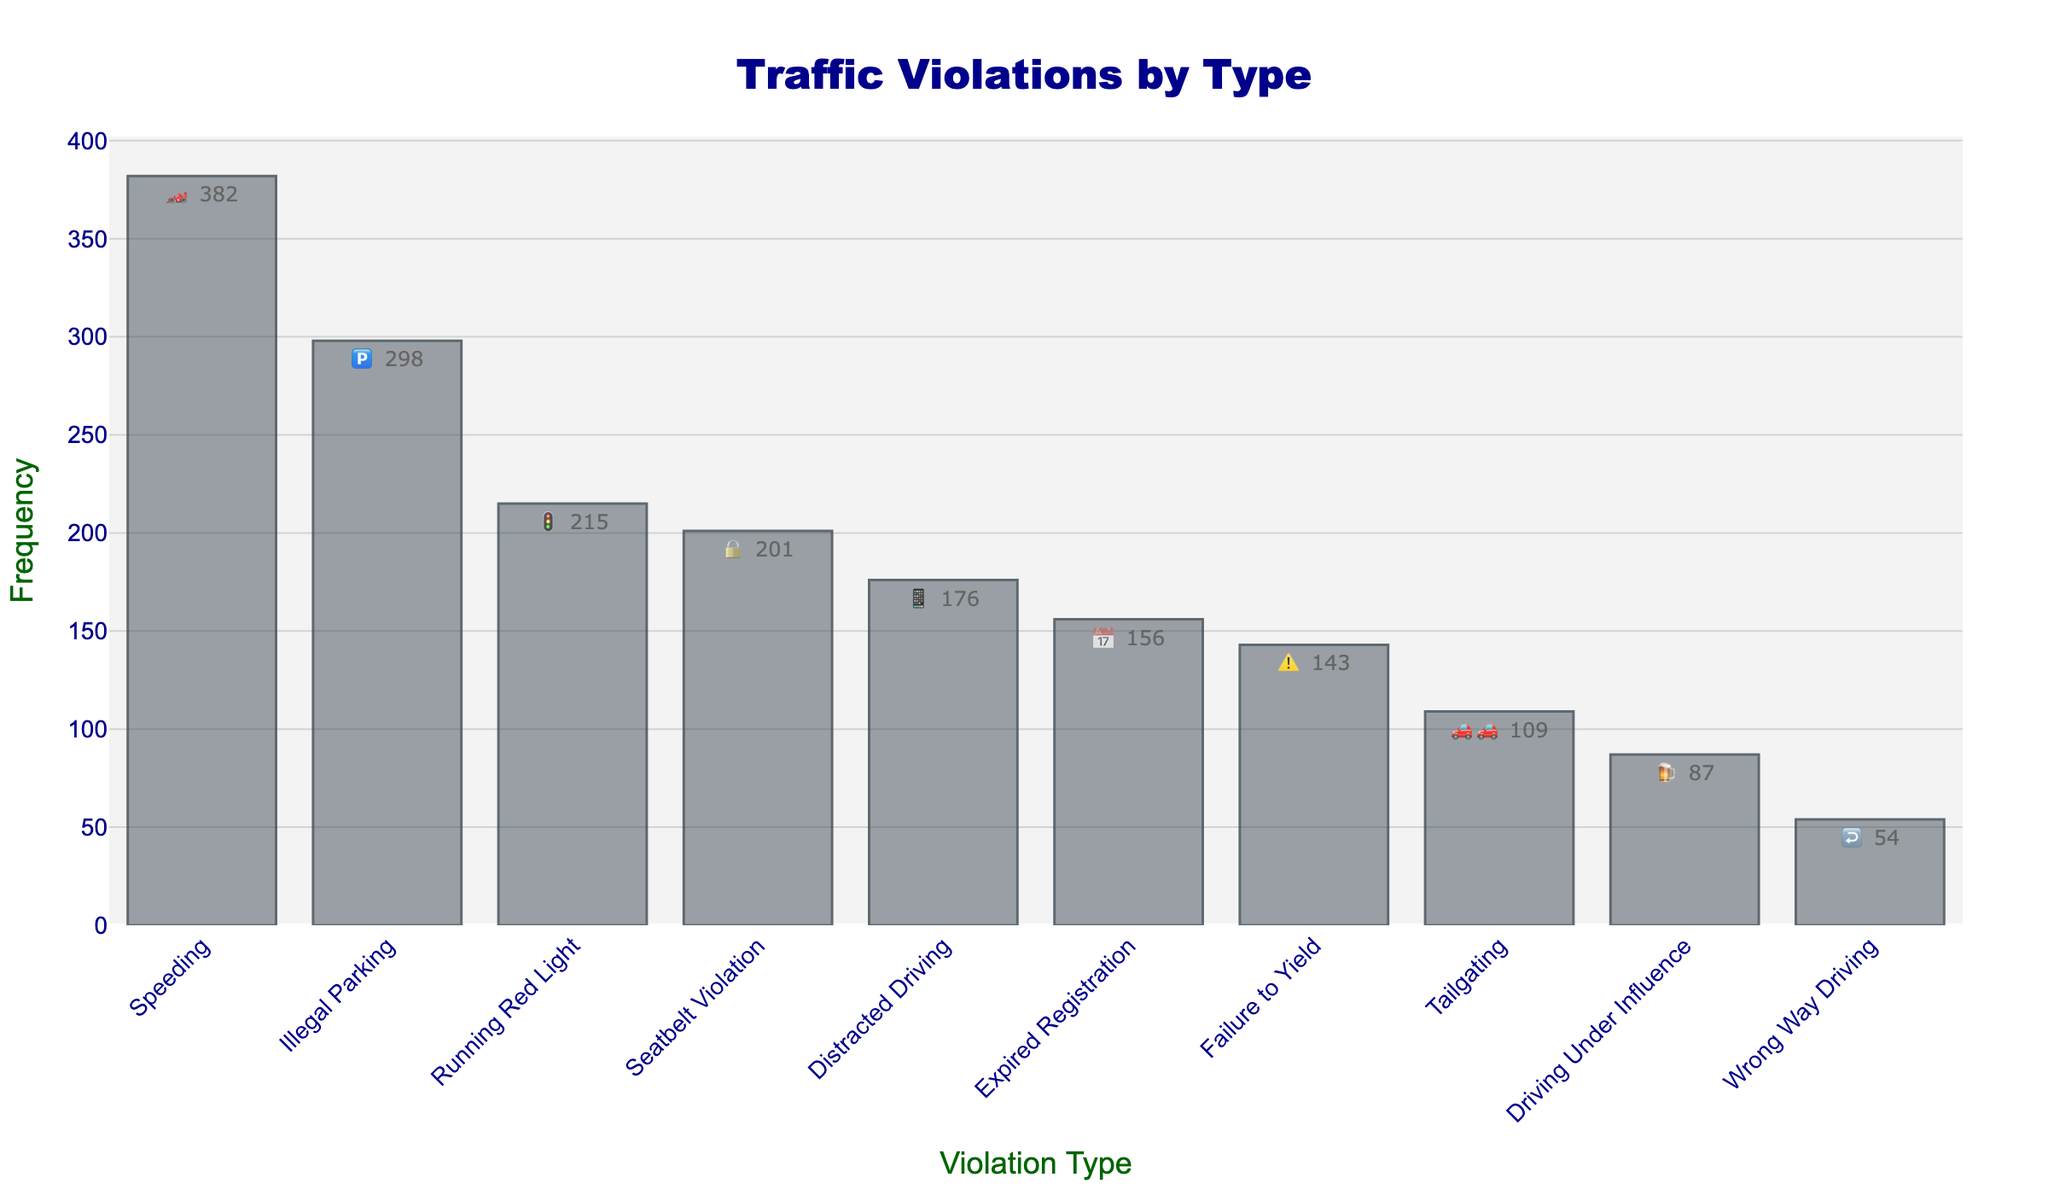What's the title of the chart? The title of the chart is usually at the top and stands out with a larger font size. The title is "Traffic Violations by Type" as indicated in the code customization section.
Answer: Traffic Violations by Type Which violation type has the highest frequency? To find the highest frequency, look for the tallest bar in the chart. The tallest bar corresponds to the type "Speeding" with a frequency of 382.
Answer: Speeding How many types of violations have a frequency higher than 200? Count the bars with values greater than 200. In this case, "Speeding," "Illegal Parking," and "Seatbelt Violation" all have frequencies above 200.
Answer: 3 What is the frequency of the "Running Red Light" violation? Look at the text or height of the bar corresponding to "Running Red Light." The frequency is 215.
Answer: 215 Which violation type is represented by the 🍺 emoji? Identify the emoji next to each bar's frequency. The 🍺 emoji is next to "Driving Under Influence."
Answer: Driving Under Influence What is the difference in frequency between "Speeding" and "Illegal Parking"? Subtract the frequency of "Illegal Parking" (298) from "Speeding" (382). The difference is 382 - 298 = 84.
Answer: 84 How many violation types have frequencies below 150? Count the bars with frequencies less than 150. "Driving Under Influence," "Wrong Way Driving," and "Tailgating" are below 150.
Answer: 3 What is the combined frequency of "Seatbelt Violation" and "Expired Registration"? Add the frequencies of these two types: 201 + 156 = 357.
Answer: 357 Which two violations have the closest frequencies? Compare the frequencies, identifying the pair with the smallest difference. "Expired Registration" (156) and "Failure to Yield" (143) are the closest with a difference of 13.
Answer: Expired Registration and Failure to Yield What's the average frequency of all the violations? Sum all the frequencies and divide by the number of violation types (10). The sum is 382+215+298+176+143+109+87+201+156+54=1821. The average is 1821 / 10 = 182.1.
Answer: 182.1 